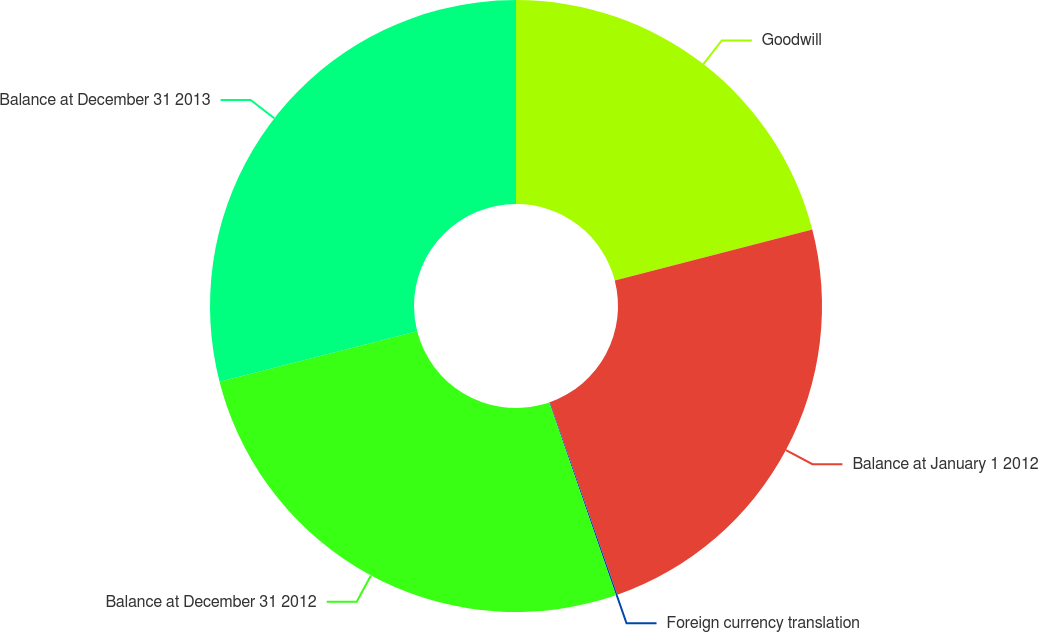Convert chart to OTSL. <chart><loc_0><loc_0><loc_500><loc_500><pie_chart><fcel>Goodwill<fcel>Balance at January 1 2012<fcel>Foreign currency translation<fcel>Balance at December 31 2012<fcel>Balance at December 31 2013<nl><fcel>20.98%<fcel>23.64%<fcel>0.08%<fcel>26.31%<fcel>28.98%<nl></chart> 